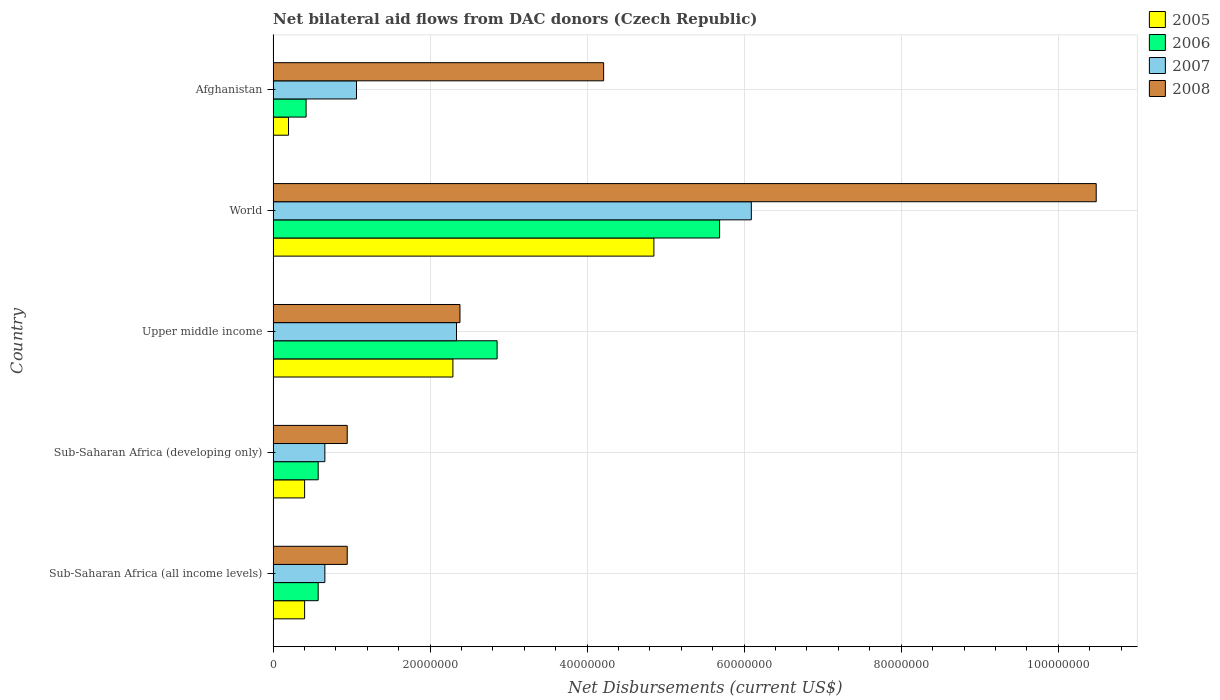How many different coloured bars are there?
Your response must be concise. 4. How many groups of bars are there?
Give a very brief answer. 5. Are the number of bars per tick equal to the number of legend labels?
Ensure brevity in your answer.  Yes. Are the number of bars on each tick of the Y-axis equal?
Make the answer very short. Yes. How many bars are there on the 1st tick from the top?
Your answer should be compact. 4. What is the label of the 1st group of bars from the top?
Your answer should be very brief. Afghanistan. What is the net bilateral aid flows in 2007 in Sub-Saharan Africa (developing only)?
Provide a short and direct response. 6.59e+06. Across all countries, what is the maximum net bilateral aid flows in 2005?
Offer a terse response. 4.85e+07. Across all countries, what is the minimum net bilateral aid flows in 2006?
Offer a very short reply. 4.20e+06. In which country was the net bilateral aid flows in 2007 maximum?
Your answer should be very brief. World. In which country was the net bilateral aid flows in 2007 minimum?
Offer a very short reply. Sub-Saharan Africa (all income levels). What is the total net bilateral aid flows in 2007 in the graph?
Your answer should be very brief. 1.08e+08. What is the difference between the net bilateral aid flows in 2007 in Sub-Saharan Africa (all income levels) and that in Upper middle income?
Your answer should be very brief. -1.68e+07. What is the difference between the net bilateral aid flows in 2005 in Sub-Saharan Africa (all income levels) and the net bilateral aid flows in 2007 in Upper middle income?
Keep it short and to the point. -1.94e+07. What is the average net bilateral aid flows in 2008 per country?
Your answer should be very brief. 3.79e+07. What is the difference between the net bilateral aid flows in 2008 and net bilateral aid flows in 2006 in Afghanistan?
Give a very brief answer. 3.79e+07. What is the ratio of the net bilateral aid flows in 2005 in Sub-Saharan Africa (all income levels) to that in Upper middle income?
Provide a short and direct response. 0.18. What is the difference between the highest and the second highest net bilateral aid flows in 2005?
Give a very brief answer. 2.56e+07. What is the difference between the highest and the lowest net bilateral aid flows in 2005?
Offer a very short reply. 4.65e+07. Is it the case that in every country, the sum of the net bilateral aid flows in 2008 and net bilateral aid flows in 2006 is greater than the sum of net bilateral aid flows in 2005 and net bilateral aid flows in 2007?
Your response must be concise. No. What does the 1st bar from the top in Afghanistan represents?
Offer a very short reply. 2008. What does the 4th bar from the bottom in Afghanistan represents?
Provide a succinct answer. 2008. Are all the bars in the graph horizontal?
Offer a very short reply. Yes. What is the difference between two consecutive major ticks on the X-axis?
Offer a very short reply. 2.00e+07. Are the values on the major ticks of X-axis written in scientific E-notation?
Ensure brevity in your answer.  No. How many legend labels are there?
Offer a very short reply. 4. What is the title of the graph?
Make the answer very short. Net bilateral aid flows from DAC donors (Czech Republic). What is the label or title of the X-axis?
Ensure brevity in your answer.  Net Disbursements (current US$). What is the Net Disbursements (current US$) in 2005 in Sub-Saharan Africa (all income levels)?
Make the answer very short. 4.01e+06. What is the Net Disbursements (current US$) in 2006 in Sub-Saharan Africa (all income levels)?
Your answer should be compact. 5.74e+06. What is the Net Disbursements (current US$) in 2007 in Sub-Saharan Africa (all income levels)?
Ensure brevity in your answer.  6.59e+06. What is the Net Disbursements (current US$) of 2008 in Sub-Saharan Africa (all income levels)?
Offer a very short reply. 9.44e+06. What is the Net Disbursements (current US$) of 2005 in Sub-Saharan Africa (developing only)?
Provide a short and direct response. 4.01e+06. What is the Net Disbursements (current US$) in 2006 in Sub-Saharan Africa (developing only)?
Offer a terse response. 5.74e+06. What is the Net Disbursements (current US$) in 2007 in Sub-Saharan Africa (developing only)?
Provide a short and direct response. 6.59e+06. What is the Net Disbursements (current US$) of 2008 in Sub-Saharan Africa (developing only)?
Offer a terse response. 9.44e+06. What is the Net Disbursements (current US$) in 2005 in Upper middle income?
Ensure brevity in your answer.  2.29e+07. What is the Net Disbursements (current US$) of 2006 in Upper middle income?
Your answer should be compact. 2.85e+07. What is the Net Disbursements (current US$) of 2007 in Upper middle income?
Give a very brief answer. 2.34e+07. What is the Net Disbursements (current US$) of 2008 in Upper middle income?
Offer a very short reply. 2.38e+07. What is the Net Disbursements (current US$) in 2005 in World?
Ensure brevity in your answer.  4.85e+07. What is the Net Disbursements (current US$) in 2006 in World?
Ensure brevity in your answer.  5.69e+07. What is the Net Disbursements (current US$) in 2007 in World?
Provide a succinct answer. 6.09e+07. What is the Net Disbursements (current US$) in 2008 in World?
Your answer should be compact. 1.05e+08. What is the Net Disbursements (current US$) in 2005 in Afghanistan?
Offer a terse response. 1.96e+06. What is the Net Disbursements (current US$) in 2006 in Afghanistan?
Make the answer very short. 4.20e+06. What is the Net Disbursements (current US$) in 2007 in Afghanistan?
Make the answer very short. 1.06e+07. What is the Net Disbursements (current US$) of 2008 in Afghanistan?
Give a very brief answer. 4.21e+07. Across all countries, what is the maximum Net Disbursements (current US$) of 2005?
Offer a terse response. 4.85e+07. Across all countries, what is the maximum Net Disbursements (current US$) of 2006?
Provide a short and direct response. 5.69e+07. Across all countries, what is the maximum Net Disbursements (current US$) in 2007?
Provide a short and direct response. 6.09e+07. Across all countries, what is the maximum Net Disbursements (current US$) in 2008?
Make the answer very short. 1.05e+08. Across all countries, what is the minimum Net Disbursements (current US$) in 2005?
Give a very brief answer. 1.96e+06. Across all countries, what is the minimum Net Disbursements (current US$) in 2006?
Ensure brevity in your answer.  4.20e+06. Across all countries, what is the minimum Net Disbursements (current US$) of 2007?
Make the answer very short. 6.59e+06. Across all countries, what is the minimum Net Disbursements (current US$) of 2008?
Ensure brevity in your answer.  9.44e+06. What is the total Net Disbursements (current US$) in 2005 in the graph?
Ensure brevity in your answer.  8.14e+07. What is the total Net Disbursements (current US$) of 2006 in the graph?
Offer a terse response. 1.01e+08. What is the total Net Disbursements (current US$) of 2007 in the graph?
Your answer should be very brief. 1.08e+08. What is the total Net Disbursements (current US$) in 2008 in the graph?
Offer a terse response. 1.90e+08. What is the difference between the Net Disbursements (current US$) in 2006 in Sub-Saharan Africa (all income levels) and that in Sub-Saharan Africa (developing only)?
Your answer should be very brief. 0. What is the difference between the Net Disbursements (current US$) in 2005 in Sub-Saharan Africa (all income levels) and that in Upper middle income?
Offer a very short reply. -1.89e+07. What is the difference between the Net Disbursements (current US$) in 2006 in Sub-Saharan Africa (all income levels) and that in Upper middle income?
Give a very brief answer. -2.28e+07. What is the difference between the Net Disbursements (current US$) in 2007 in Sub-Saharan Africa (all income levels) and that in Upper middle income?
Make the answer very short. -1.68e+07. What is the difference between the Net Disbursements (current US$) of 2008 in Sub-Saharan Africa (all income levels) and that in Upper middle income?
Provide a short and direct response. -1.44e+07. What is the difference between the Net Disbursements (current US$) in 2005 in Sub-Saharan Africa (all income levels) and that in World?
Keep it short and to the point. -4.45e+07. What is the difference between the Net Disbursements (current US$) of 2006 in Sub-Saharan Africa (all income levels) and that in World?
Keep it short and to the point. -5.11e+07. What is the difference between the Net Disbursements (current US$) in 2007 in Sub-Saharan Africa (all income levels) and that in World?
Give a very brief answer. -5.43e+07. What is the difference between the Net Disbursements (current US$) in 2008 in Sub-Saharan Africa (all income levels) and that in World?
Ensure brevity in your answer.  -9.54e+07. What is the difference between the Net Disbursements (current US$) in 2005 in Sub-Saharan Africa (all income levels) and that in Afghanistan?
Ensure brevity in your answer.  2.05e+06. What is the difference between the Net Disbursements (current US$) of 2006 in Sub-Saharan Africa (all income levels) and that in Afghanistan?
Make the answer very short. 1.54e+06. What is the difference between the Net Disbursements (current US$) of 2007 in Sub-Saharan Africa (all income levels) and that in Afghanistan?
Offer a very short reply. -4.03e+06. What is the difference between the Net Disbursements (current US$) in 2008 in Sub-Saharan Africa (all income levels) and that in Afghanistan?
Keep it short and to the point. -3.27e+07. What is the difference between the Net Disbursements (current US$) in 2005 in Sub-Saharan Africa (developing only) and that in Upper middle income?
Ensure brevity in your answer.  -1.89e+07. What is the difference between the Net Disbursements (current US$) of 2006 in Sub-Saharan Africa (developing only) and that in Upper middle income?
Provide a succinct answer. -2.28e+07. What is the difference between the Net Disbursements (current US$) of 2007 in Sub-Saharan Africa (developing only) and that in Upper middle income?
Provide a succinct answer. -1.68e+07. What is the difference between the Net Disbursements (current US$) of 2008 in Sub-Saharan Africa (developing only) and that in Upper middle income?
Give a very brief answer. -1.44e+07. What is the difference between the Net Disbursements (current US$) of 2005 in Sub-Saharan Africa (developing only) and that in World?
Keep it short and to the point. -4.45e+07. What is the difference between the Net Disbursements (current US$) in 2006 in Sub-Saharan Africa (developing only) and that in World?
Your answer should be compact. -5.11e+07. What is the difference between the Net Disbursements (current US$) of 2007 in Sub-Saharan Africa (developing only) and that in World?
Provide a short and direct response. -5.43e+07. What is the difference between the Net Disbursements (current US$) in 2008 in Sub-Saharan Africa (developing only) and that in World?
Give a very brief answer. -9.54e+07. What is the difference between the Net Disbursements (current US$) of 2005 in Sub-Saharan Africa (developing only) and that in Afghanistan?
Your answer should be compact. 2.05e+06. What is the difference between the Net Disbursements (current US$) in 2006 in Sub-Saharan Africa (developing only) and that in Afghanistan?
Offer a very short reply. 1.54e+06. What is the difference between the Net Disbursements (current US$) of 2007 in Sub-Saharan Africa (developing only) and that in Afghanistan?
Keep it short and to the point. -4.03e+06. What is the difference between the Net Disbursements (current US$) in 2008 in Sub-Saharan Africa (developing only) and that in Afghanistan?
Ensure brevity in your answer.  -3.27e+07. What is the difference between the Net Disbursements (current US$) in 2005 in Upper middle income and that in World?
Provide a succinct answer. -2.56e+07. What is the difference between the Net Disbursements (current US$) in 2006 in Upper middle income and that in World?
Provide a succinct answer. -2.83e+07. What is the difference between the Net Disbursements (current US$) in 2007 in Upper middle income and that in World?
Keep it short and to the point. -3.76e+07. What is the difference between the Net Disbursements (current US$) in 2008 in Upper middle income and that in World?
Ensure brevity in your answer.  -8.10e+07. What is the difference between the Net Disbursements (current US$) of 2005 in Upper middle income and that in Afghanistan?
Your answer should be very brief. 2.09e+07. What is the difference between the Net Disbursements (current US$) in 2006 in Upper middle income and that in Afghanistan?
Your answer should be very brief. 2.43e+07. What is the difference between the Net Disbursements (current US$) of 2007 in Upper middle income and that in Afghanistan?
Make the answer very short. 1.27e+07. What is the difference between the Net Disbursements (current US$) in 2008 in Upper middle income and that in Afghanistan?
Offer a terse response. -1.83e+07. What is the difference between the Net Disbursements (current US$) of 2005 in World and that in Afghanistan?
Provide a succinct answer. 4.65e+07. What is the difference between the Net Disbursements (current US$) in 2006 in World and that in Afghanistan?
Your response must be concise. 5.27e+07. What is the difference between the Net Disbursements (current US$) in 2007 in World and that in Afghanistan?
Your answer should be compact. 5.03e+07. What is the difference between the Net Disbursements (current US$) in 2008 in World and that in Afghanistan?
Provide a short and direct response. 6.27e+07. What is the difference between the Net Disbursements (current US$) of 2005 in Sub-Saharan Africa (all income levels) and the Net Disbursements (current US$) of 2006 in Sub-Saharan Africa (developing only)?
Provide a succinct answer. -1.73e+06. What is the difference between the Net Disbursements (current US$) of 2005 in Sub-Saharan Africa (all income levels) and the Net Disbursements (current US$) of 2007 in Sub-Saharan Africa (developing only)?
Provide a succinct answer. -2.58e+06. What is the difference between the Net Disbursements (current US$) in 2005 in Sub-Saharan Africa (all income levels) and the Net Disbursements (current US$) in 2008 in Sub-Saharan Africa (developing only)?
Your answer should be compact. -5.43e+06. What is the difference between the Net Disbursements (current US$) of 2006 in Sub-Saharan Africa (all income levels) and the Net Disbursements (current US$) of 2007 in Sub-Saharan Africa (developing only)?
Provide a short and direct response. -8.50e+05. What is the difference between the Net Disbursements (current US$) in 2006 in Sub-Saharan Africa (all income levels) and the Net Disbursements (current US$) in 2008 in Sub-Saharan Africa (developing only)?
Ensure brevity in your answer.  -3.70e+06. What is the difference between the Net Disbursements (current US$) of 2007 in Sub-Saharan Africa (all income levels) and the Net Disbursements (current US$) of 2008 in Sub-Saharan Africa (developing only)?
Your answer should be compact. -2.85e+06. What is the difference between the Net Disbursements (current US$) of 2005 in Sub-Saharan Africa (all income levels) and the Net Disbursements (current US$) of 2006 in Upper middle income?
Offer a very short reply. -2.45e+07. What is the difference between the Net Disbursements (current US$) of 2005 in Sub-Saharan Africa (all income levels) and the Net Disbursements (current US$) of 2007 in Upper middle income?
Your answer should be compact. -1.94e+07. What is the difference between the Net Disbursements (current US$) in 2005 in Sub-Saharan Africa (all income levels) and the Net Disbursements (current US$) in 2008 in Upper middle income?
Keep it short and to the point. -1.98e+07. What is the difference between the Net Disbursements (current US$) in 2006 in Sub-Saharan Africa (all income levels) and the Net Disbursements (current US$) in 2007 in Upper middle income?
Offer a terse response. -1.76e+07. What is the difference between the Net Disbursements (current US$) of 2006 in Sub-Saharan Africa (all income levels) and the Net Disbursements (current US$) of 2008 in Upper middle income?
Keep it short and to the point. -1.81e+07. What is the difference between the Net Disbursements (current US$) in 2007 in Sub-Saharan Africa (all income levels) and the Net Disbursements (current US$) in 2008 in Upper middle income?
Offer a very short reply. -1.72e+07. What is the difference between the Net Disbursements (current US$) in 2005 in Sub-Saharan Africa (all income levels) and the Net Disbursements (current US$) in 2006 in World?
Offer a terse response. -5.29e+07. What is the difference between the Net Disbursements (current US$) in 2005 in Sub-Saharan Africa (all income levels) and the Net Disbursements (current US$) in 2007 in World?
Offer a terse response. -5.69e+07. What is the difference between the Net Disbursements (current US$) of 2005 in Sub-Saharan Africa (all income levels) and the Net Disbursements (current US$) of 2008 in World?
Provide a short and direct response. -1.01e+08. What is the difference between the Net Disbursements (current US$) of 2006 in Sub-Saharan Africa (all income levels) and the Net Disbursements (current US$) of 2007 in World?
Keep it short and to the point. -5.52e+07. What is the difference between the Net Disbursements (current US$) in 2006 in Sub-Saharan Africa (all income levels) and the Net Disbursements (current US$) in 2008 in World?
Give a very brief answer. -9.91e+07. What is the difference between the Net Disbursements (current US$) in 2007 in Sub-Saharan Africa (all income levels) and the Net Disbursements (current US$) in 2008 in World?
Provide a short and direct response. -9.82e+07. What is the difference between the Net Disbursements (current US$) of 2005 in Sub-Saharan Africa (all income levels) and the Net Disbursements (current US$) of 2006 in Afghanistan?
Make the answer very short. -1.90e+05. What is the difference between the Net Disbursements (current US$) of 2005 in Sub-Saharan Africa (all income levels) and the Net Disbursements (current US$) of 2007 in Afghanistan?
Ensure brevity in your answer.  -6.61e+06. What is the difference between the Net Disbursements (current US$) in 2005 in Sub-Saharan Africa (all income levels) and the Net Disbursements (current US$) in 2008 in Afghanistan?
Provide a succinct answer. -3.81e+07. What is the difference between the Net Disbursements (current US$) of 2006 in Sub-Saharan Africa (all income levels) and the Net Disbursements (current US$) of 2007 in Afghanistan?
Your answer should be very brief. -4.88e+06. What is the difference between the Net Disbursements (current US$) of 2006 in Sub-Saharan Africa (all income levels) and the Net Disbursements (current US$) of 2008 in Afghanistan?
Provide a short and direct response. -3.64e+07. What is the difference between the Net Disbursements (current US$) of 2007 in Sub-Saharan Africa (all income levels) and the Net Disbursements (current US$) of 2008 in Afghanistan?
Give a very brief answer. -3.55e+07. What is the difference between the Net Disbursements (current US$) in 2005 in Sub-Saharan Africa (developing only) and the Net Disbursements (current US$) in 2006 in Upper middle income?
Offer a very short reply. -2.45e+07. What is the difference between the Net Disbursements (current US$) in 2005 in Sub-Saharan Africa (developing only) and the Net Disbursements (current US$) in 2007 in Upper middle income?
Your answer should be compact. -1.94e+07. What is the difference between the Net Disbursements (current US$) of 2005 in Sub-Saharan Africa (developing only) and the Net Disbursements (current US$) of 2008 in Upper middle income?
Make the answer very short. -1.98e+07. What is the difference between the Net Disbursements (current US$) of 2006 in Sub-Saharan Africa (developing only) and the Net Disbursements (current US$) of 2007 in Upper middle income?
Offer a terse response. -1.76e+07. What is the difference between the Net Disbursements (current US$) of 2006 in Sub-Saharan Africa (developing only) and the Net Disbursements (current US$) of 2008 in Upper middle income?
Your answer should be very brief. -1.81e+07. What is the difference between the Net Disbursements (current US$) of 2007 in Sub-Saharan Africa (developing only) and the Net Disbursements (current US$) of 2008 in Upper middle income?
Your response must be concise. -1.72e+07. What is the difference between the Net Disbursements (current US$) of 2005 in Sub-Saharan Africa (developing only) and the Net Disbursements (current US$) of 2006 in World?
Offer a terse response. -5.29e+07. What is the difference between the Net Disbursements (current US$) in 2005 in Sub-Saharan Africa (developing only) and the Net Disbursements (current US$) in 2007 in World?
Provide a succinct answer. -5.69e+07. What is the difference between the Net Disbursements (current US$) of 2005 in Sub-Saharan Africa (developing only) and the Net Disbursements (current US$) of 2008 in World?
Offer a terse response. -1.01e+08. What is the difference between the Net Disbursements (current US$) of 2006 in Sub-Saharan Africa (developing only) and the Net Disbursements (current US$) of 2007 in World?
Offer a terse response. -5.52e+07. What is the difference between the Net Disbursements (current US$) in 2006 in Sub-Saharan Africa (developing only) and the Net Disbursements (current US$) in 2008 in World?
Your answer should be very brief. -9.91e+07. What is the difference between the Net Disbursements (current US$) in 2007 in Sub-Saharan Africa (developing only) and the Net Disbursements (current US$) in 2008 in World?
Make the answer very short. -9.82e+07. What is the difference between the Net Disbursements (current US$) of 2005 in Sub-Saharan Africa (developing only) and the Net Disbursements (current US$) of 2007 in Afghanistan?
Offer a terse response. -6.61e+06. What is the difference between the Net Disbursements (current US$) of 2005 in Sub-Saharan Africa (developing only) and the Net Disbursements (current US$) of 2008 in Afghanistan?
Your answer should be very brief. -3.81e+07. What is the difference between the Net Disbursements (current US$) of 2006 in Sub-Saharan Africa (developing only) and the Net Disbursements (current US$) of 2007 in Afghanistan?
Your answer should be compact. -4.88e+06. What is the difference between the Net Disbursements (current US$) of 2006 in Sub-Saharan Africa (developing only) and the Net Disbursements (current US$) of 2008 in Afghanistan?
Your answer should be compact. -3.64e+07. What is the difference between the Net Disbursements (current US$) of 2007 in Sub-Saharan Africa (developing only) and the Net Disbursements (current US$) of 2008 in Afghanistan?
Offer a very short reply. -3.55e+07. What is the difference between the Net Disbursements (current US$) in 2005 in Upper middle income and the Net Disbursements (current US$) in 2006 in World?
Your response must be concise. -3.40e+07. What is the difference between the Net Disbursements (current US$) in 2005 in Upper middle income and the Net Disbursements (current US$) in 2007 in World?
Your answer should be very brief. -3.80e+07. What is the difference between the Net Disbursements (current US$) in 2005 in Upper middle income and the Net Disbursements (current US$) in 2008 in World?
Your response must be concise. -8.19e+07. What is the difference between the Net Disbursements (current US$) of 2006 in Upper middle income and the Net Disbursements (current US$) of 2007 in World?
Provide a succinct answer. -3.24e+07. What is the difference between the Net Disbursements (current US$) of 2006 in Upper middle income and the Net Disbursements (current US$) of 2008 in World?
Your answer should be very brief. -7.63e+07. What is the difference between the Net Disbursements (current US$) of 2007 in Upper middle income and the Net Disbursements (current US$) of 2008 in World?
Provide a short and direct response. -8.15e+07. What is the difference between the Net Disbursements (current US$) of 2005 in Upper middle income and the Net Disbursements (current US$) of 2006 in Afghanistan?
Ensure brevity in your answer.  1.87e+07. What is the difference between the Net Disbursements (current US$) in 2005 in Upper middle income and the Net Disbursements (current US$) in 2007 in Afghanistan?
Your answer should be very brief. 1.23e+07. What is the difference between the Net Disbursements (current US$) in 2005 in Upper middle income and the Net Disbursements (current US$) in 2008 in Afghanistan?
Give a very brief answer. -1.92e+07. What is the difference between the Net Disbursements (current US$) in 2006 in Upper middle income and the Net Disbursements (current US$) in 2007 in Afghanistan?
Offer a very short reply. 1.79e+07. What is the difference between the Net Disbursements (current US$) in 2006 in Upper middle income and the Net Disbursements (current US$) in 2008 in Afghanistan?
Make the answer very short. -1.36e+07. What is the difference between the Net Disbursements (current US$) of 2007 in Upper middle income and the Net Disbursements (current US$) of 2008 in Afghanistan?
Your response must be concise. -1.87e+07. What is the difference between the Net Disbursements (current US$) in 2005 in World and the Net Disbursements (current US$) in 2006 in Afghanistan?
Your response must be concise. 4.43e+07. What is the difference between the Net Disbursements (current US$) in 2005 in World and the Net Disbursements (current US$) in 2007 in Afghanistan?
Your response must be concise. 3.79e+07. What is the difference between the Net Disbursements (current US$) in 2005 in World and the Net Disbursements (current US$) in 2008 in Afghanistan?
Your answer should be very brief. 6.40e+06. What is the difference between the Net Disbursements (current US$) in 2006 in World and the Net Disbursements (current US$) in 2007 in Afghanistan?
Ensure brevity in your answer.  4.62e+07. What is the difference between the Net Disbursements (current US$) in 2006 in World and the Net Disbursements (current US$) in 2008 in Afghanistan?
Your answer should be very brief. 1.48e+07. What is the difference between the Net Disbursements (current US$) in 2007 in World and the Net Disbursements (current US$) in 2008 in Afghanistan?
Your answer should be very brief. 1.88e+07. What is the average Net Disbursements (current US$) in 2005 per country?
Provide a short and direct response. 1.63e+07. What is the average Net Disbursements (current US$) in 2006 per country?
Your answer should be compact. 2.02e+07. What is the average Net Disbursements (current US$) of 2007 per country?
Provide a short and direct response. 2.16e+07. What is the average Net Disbursements (current US$) of 2008 per country?
Your answer should be compact. 3.79e+07. What is the difference between the Net Disbursements (current US$) of 2005 and Net Disbursements (current US$) of 2006 in Sub-Saharan Africa (all income levels)?
Your answer should be very brief. -1.73e+06. What is the difference between the Net Disbursements (current US$) in 2005 and Net Disbursements (current US$) in 2007 in Sub-Saharan Africa (all income levels)?
Your answer should be compact. -2.58e+06. What is the difference between the Net Disbursements (current US$) of 2005 and Net Disbursements (current US$) of 2008 in Sub-Saharan Africa (all income levels)?
Offer a very short reply. -5.43e+06. What is the difference between the Net Disbursements (current US$) in 2006 and Net Disbursements (current US$) in 2007 in Sub-Saharan Africa (all income levels)?
Offer a terse response. -8.50e+05. What is the difference between the Net Disbursements (current US$) of 2006 and Net Disbursements (current US$) of 2008 in Sub-Saharan Africa (all income levels)?
Make the answer very short. -3.70e+06. What is the difference between the Net Disbursements (current US$) of 2007 and Net Disbursements (current US$) of 2008 in Sub-Saharan Africa (all income levels)?
Offer a terse response. -2.85e+06. What is the difference between the Net Disbursements (current US$) in 2005 and Net Disbursements (current US$) in 2006 in Sub-Saharan Africa (developing only)?
Provide a succinct answer. -1.73e+06. What is the difference between the Net Disbursements (current US$) of 2005 and Net Disbursements (current US$) of 2007 in Sub-Saharan Africa (developing only)?
Ensure brevity in your answer.  -2.58e+06. What is the difference between the Net Disbursements (current US$) in 2005 and Net Disbursements (current US$) in 2008 in Sub-Saharan Africa (developing only)?
Your response must be concise. -5.43e+06. What is the difference between the Net Disbursements (current US$) in 2006 and Net Disbursements (current US$) in 2007 in Sub-Saharan Africa (developing only)?
Keep it short and to the point. -8.50e+05. What is the difference between the Net Disbursements (current US$) of 2006 and Net Disbursements (current US$) of 2008 in Sub-Saharan Africa (developing only)?
Your answer should be compact. -3.70e+06. What is the difference between the Net Disbursements (current US$) in 2007 and Net Disbursements (current US$) in 2008 in Sub-Saharan Africa (developing only)?
Your response must be concise. -2.85e+06. What is the difference between the Net Disbursements (current US$) of 2005 and Net Disbursements (current US$) of 2006 in Upper middle income?
Your answer should be compact. -5.63e+06. What is the difference between the Net Disbursements (current US$) of 2005 and Net Disbursements (current US$) of 2007 in Upper middle income?
Your answer should be very brief. -4.60e+05. What is the difference between the Net Disbursements (current US$) of 2005 and Net Disbursements (current US$) of 2008 in Upper middle income?
Provide a succinct answer. -9.00e+05. What is the difference between the Net Disbursements (current US$) of 2006 and Net Disbursements (current US$) of 2007 in Upper middle income?
Offer a very short reply. 5.17e+06. What is the difference between the Net Disbursements (current US$) in 2006 and Net Disbursements (current US$) in 2008 in Upper middle income?
Offer a terse response. 4.73e+06. What is the difference between the Net Disbursements (current US$) in 2007 and Net Disbursements (current US$) in 2008 in Upper middle income?
Provide a short and direct response. -4.40e+05. What is the difference between the Net Disbursements (current US$) in 2005 and Net Disbursements (current US$) in 2006 in World?
Give a very brief answer. -8.37e+06. What is the difference between the Net Disbursements (current US$) of 2005 and Net Disbursements (current US$) of 2007 in World?
Your response must be concise. -1.24e+07. What is the difference between the Net Disbursements (current US$) in 2005 and Net Disbursements (current US$) in 2008 in World?
Your response must be concise. -5.63e+07. What is the difference between the Net Disbursements (current US$) of 2006 and Net Disbursements (current US$) of 2007 in World?
Offer a very short reply. -4.04e+06. What is the difference between the Net Disbursements (current US$) of 2006 and Net Disbursements (current US$) of 2008 in World?
Your answer should be compact. -4.80e+07. What is the difference between the Net Disbursements (current US$) of 2007 and Net Disbursements (current US$) of 2008 in World?
Give a very brief answer. -4.39e+07. What is the difference between the Net Disbursements (current US$) of 2005 and Net Disbursements (current US$) of 2006 in Afghanistan?
Your response must be concise. -2.24e+06. What is the difference between the Net Disbursements (current US$) of 2005 and Net Disbursements (current US$) of 2007 in Afghanistan?
Keep it short and to the point. -8.66e+06. What is the difference between the Net Disbursements (current US$) in 2005 and Net Disbursements (current US$) in 2008 in Afghanistan?
Ensure brevity in your answer.  -4.01e+07. What is the difference between the Net Disbursements (current US$) of 2006 and Net Disbursements (current US$) of 2007 in Afghanistan?
Ensure brevity in your answer.  -6.42e+06. What is the difference between the Net Disbursements (current US$) in 2006 and Net Disbursements (current US$) in 2008 in Afghanistan?
Your answer should be very brief. -3.79e+07. What is the difference between the Net Disbursements (current US$) in 2007 and Net Disbursements (current US$) in 2008 in Afghanistan?
Make the answer very short. -3.15e+07. What is the ratio of the Net Disbursements (current US$) in 2005 in Sub-Saharan Africa (all income levels) to that in Sub-Saharan Africa (developing only)?
Make the answer very short. 1. What is the ratio of the Net Disbursements (current US$) in 2006 in Sub-Saharan Africa (all income levels) to that in Sub-Saharan Africa (developing only)?
Provide a succinct answer. 1. What is the ratio of the Net Disbursements (current US$) of 2007 in Sub-Saharan Africa (all income levels) to that in Sub-Saharan Africa (developing only)?
Your response must be concise. 1. What is the ratio of the Net Disbursements (current US$) of 2005 in Sub-Saharan Africa (all income levels) to that in Upper middle income?
Give a very brief answer. 0.18. What is the ratio of the Net Disbursements (current US$) of 2006 in Sub-Saharan Africa (all income levels) to that in Upper middle income?
Your answer should be very brief. 0.2. What is the ratio of the Net Disbursements (current US$) in 2007 in Sub-Saharan Africa (all income levels) to that in Upper middle income?
Your answer should be compact. 0.28. What is the ratio of the Net Disbursements (current US$) of 2008 in Sub-Saharan Africa (all income levels) to that in Upper middle income?
Your answer should be very brief. 0.4. What is the ratio of the Net Disbursements (current US$) of 2005 in Sub-Saharan Africa (all income levels) to that in World?
Ensure brevity in your answer.  0.08. What is the ratio of the Net Disbursements (current US$) in 2006 in Sub-Saharan Africa (all income levels) to that in World?
Your response must be concise. 0.1. What is the ratio of the Net Disbursements (current US$) in 2007 in Sub-Saharan Africa (all income levels) to that in World?
Offer a terse response. 0.11. What is the ratio of the Net Disbursements (current US$) in 2008 in Sub-Saharan Africa (all income levels) to that in World?
Your answer should be very brief. 0.09. What is the ratio of the Net Disbursements (current US$) of 2005 in Sub-Saharan Africa (all income levels) to that in Afghanistan?
Your response must be concise. 2.05. What is the ratio of the Net Disbursements (current US$) in 2006 in Sub-Saharan Africa (all income levels) to that in Afghanistan?
Keep it short and to the point. 1.37. What is the ratio of the Net Disbursements (current US$) of 2007 in Sub-Saharan Africa (all income levels) to that in Afghanistan?
Give a very brief answer. 0.62. What is the ratio of the Net Disbursements (current US$) in 2008 in Sub-Saharan Africa (all income levels) to that in Afghanistan?
Ensure brevity in your answer.  0.22. What is the ratio of the Net Disbursements (current US$) of 2005 in Sub-Saharan Africa (developing only) to that in Upper middle income?
Give a very brief answer. 0.18. What is the ratio of the Net Disbursements (current US$) of 2006 in Sub-Saharan Africa (developing only) to that in Upper middle income?
Your answer should be very brief. 0.2. What is the ratio of the Net Disbursements (current US$) in 2007 in Sub-Saharan Africa (developing only) to that in Upper middle income?
Your answer should be compact. 0.28. What is the ratio of the Net Disbursements (current US$) of 2008 in Sub-Saharan Africa (developing only) to that in Upper middle income?
Ensure brevity in your answer.  0.4. What is the ratio of the Net Disbursements (current US$) of 2005 in Sub-Saharan Africa (developing only) to that in World?
Provide a short and direct response. 0.08. What is the ratio of the Net Disbursements (current US$) of 2006 in Sub-Saharan Africa (developing only) to that in World?
Provide a short and direct response. 0.1. What is the ratio of the Net Disbursements (current US$) of 2007 in Sub-Saharan Africa (developing only) to that in World?
Offer a very short reply. 0.11. What is the ratio of the Net Disbursements (current US$) in 2008 in Sub-Saharan Africa (developing only) to that in World?
Provide a succinct answer. 0.09. What is the ratio of the Net Disbursements (current US$) in 2005 in Sub-Saharan Africa (developing only) to that in Afghanistan?
Provide a succinct answer. 2.05. What is the ratio of the Net Disbursements (current US$) of 2006 in Sub-Saharan Africa (developing only) to that in Afghanistan?
Keep it short and to the point. 1.37. What is the ratio of the Net Disbursements (current US$) of 2007 in Sub-Saharan Africa (developing only) to that in Afghanistan?
Give a very brief answer. 0.62. What is the ratio of the Net Disbursements (current US$) of 2008 in Sub-Saharan Africa (developing only) to that in Afghanistan?
Your answer should be compact. 0.22. What is the ratio of the Net Disbursements (current US$) of 2005 in Upper middle income to that in World?
Your answer should be very brief. 0.47. What is the ratio of the Net Disbursements (current US$) in 2006 in Upper middle income to that in World?
Provide a short and direct response. 0.5. What is the ratio of the Net Disbursements (current US$) in 2007 in Upper middle income to that in World?
Your answer should be very brief. 0.38. What is the ratio of the Net Disbursements (current US$) of 2008 in Upper middle income to that in World?
Ensure brevity in your answer.  0.23. What is the ratio of the Net Disbursements (current US$) of 2005 in Upper middle income to that in Afghanistan?
Give a very brief answer. 11.68. What is the ratio of the Net Disbursements (current US$) of 2006 in Upper middle income to that in Afghanistan?
Offer a very short reply. 6.79. What is the ratio of the Net Disbursements (current US$) in 2007 in Upper middle income to that in Afghanistan?
Your answer should be compact. 2.2. What is the ratio of the Net Disbursements (current US$) of 2008 in Upper middle income to that in Afghanistan?
Offer a terse response. 0.57. What is the ratio of the Net Disbursements (current US$) of 2005 in World to that in Afghanistan?
Your answer should be compact. 24.74. What is the ratio of the Net Disbursements (current US$) of 2006 in World to that in Afghanistan?
Provide a succinct answer. 13.54. What is the ratio of the Net Disbursements (current US$) in 2007 in World to that in Afghanistan?
Provide a succinct answer. 5.74. What is the ratio of the Net Disbursements (current US$) of 2008 in World to that in Afghanistan?
Ensure brevity in your answer.  2.49. What is the difference between the highest and the second highest Net Disbursements (current US$) in 2005?
Give a very brief answer. 2.56e+07. What is the difference between the highest and the second highest Net Disbursements (current US$) in 2006?
Make the answer very short. 2.83e+07. What is the difference between the highest and the second highest Net Disbursements (current US$) in 2007?
Keep it short and to the point. 3.76e+07. What is the difference between the highest and the second highest Net Disbursements (current US$) of 2008?
Ensure brevity in your answer.  6.27e+07. What is the difference between the highest and the lowest Net Disbursements (current US$) in 2005?
Ensure brevity in your answer.  4.65e+07. What is the difference between the highest and the lowest Net Disbursements (current US$) in 2006?
Ensure brevity in your answer.  5.27e+07. What is the difference between the highest and the lowest Net Disbursements (current US$) of 2007?
Give a very brief answer. 5.43e+07. What is the difference between the highest and the lowest Net Disbursements (current US$) in 2008?
Provide a succinct answer. 9.54e+07. 